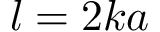Convert formula to latex. <formula><loc_0><loc_0><loc_500><loc_500>l = 2 k a</formula> 